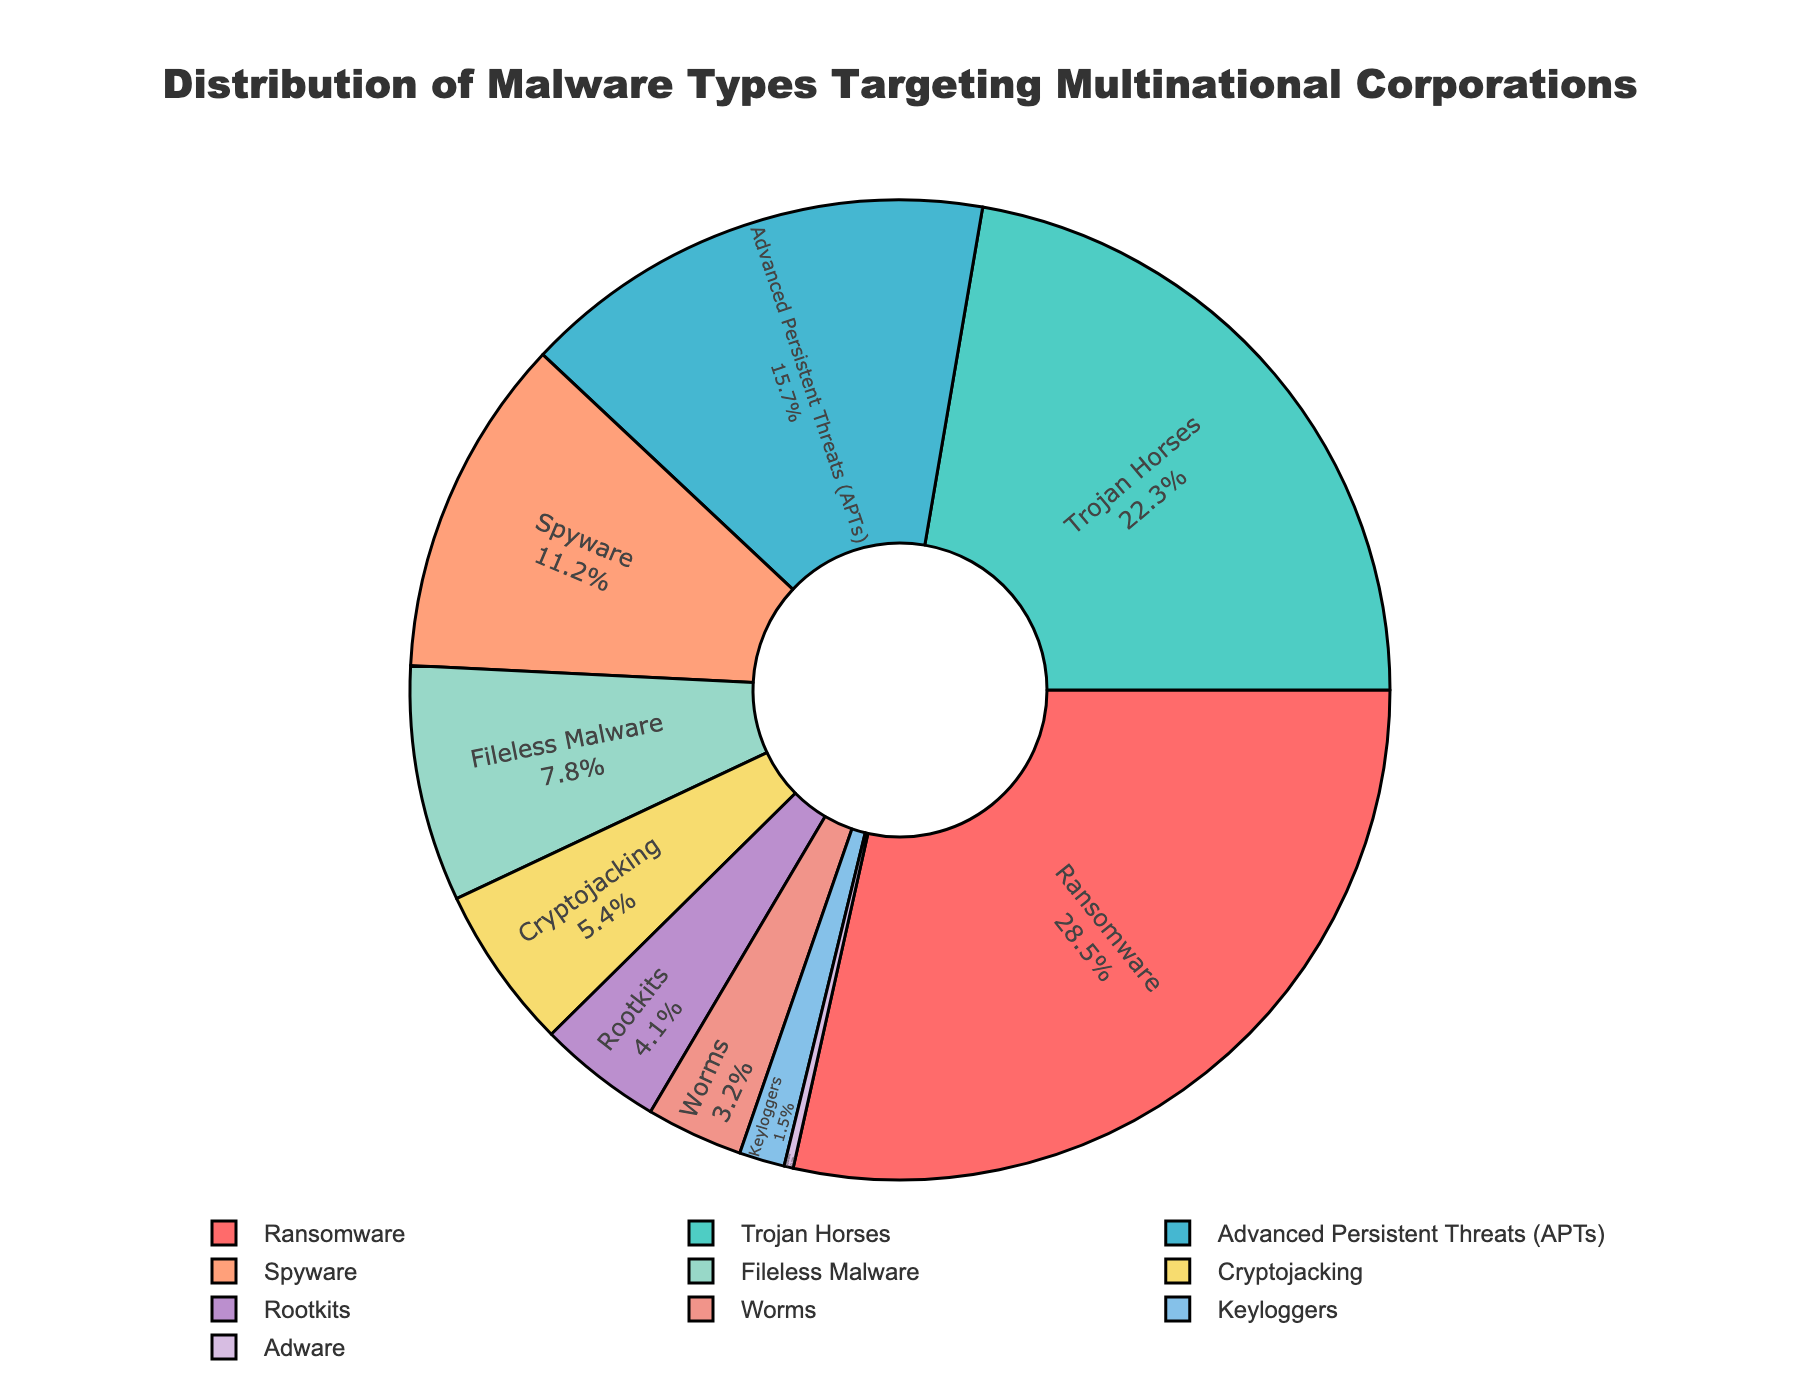What is the most common type of malware targeting multinational corporations? The figure shows different malware types with their respective percentages. The largest segment is labeled "Ransomware" with 28.5%, indicating it's the most common type.
Answer: Ransomware Which type of malware has a larger percentage: Spyware or Cryptojacking? From the figure, Spyware has 11.2%, and Cryptojacking has 5.4%. Since 11.2% is greater than 5.4%, Spyware has a larger percentage.
Answer: Spyware What is the combined percentage of Trojan Horses and Rootkits? Trojan Horses have 22.3%, and Rootkits have 4.1%. The combined percentage is 22.3% + 4.1% = 26.4%.
Answer: 26.4% Which is the least common type of malware? The smallest segment in the pie chart represents Adware, which has a percentage of 0.3%.
Answer: Adware How much more common is Ransomware compared to Worms? Ransomware has 28.5%, and Worms have 3.2%. The difference is 28.5% - 3.2% = 25.3%.
Answer: 25.3% What's the difference in percentage between Advanced Persistent Threats (APTs) and Fileless Malware? Advanced Persistent Threats (APTs) have 15.7%. Fileless Malware has 7.8%. The difference is 15.7% - 7.8% = 7.9%.
Answer: 7.9% If you combine the percentages of the four least common malware types, what is the total percentage? The four least common malware types are Worms (3.2%), Keyloggers (1.5%), and Adware (0.3%). Their total percentage is 3.2% + 1.5% + 0.3% = 5.0%.
Answer: 5.0% Which malware types have a percentage greater than 10%? The chart shows that Ransomware (28.5%), Trojan Horses (22.3%), Advanced Persistent Threats (15.7%), and Spyware (11.2%) each have percentages greater than 10%.
Answer: Ransomware, Trojan Horses, Advanced Persistent Threats, Spyware 